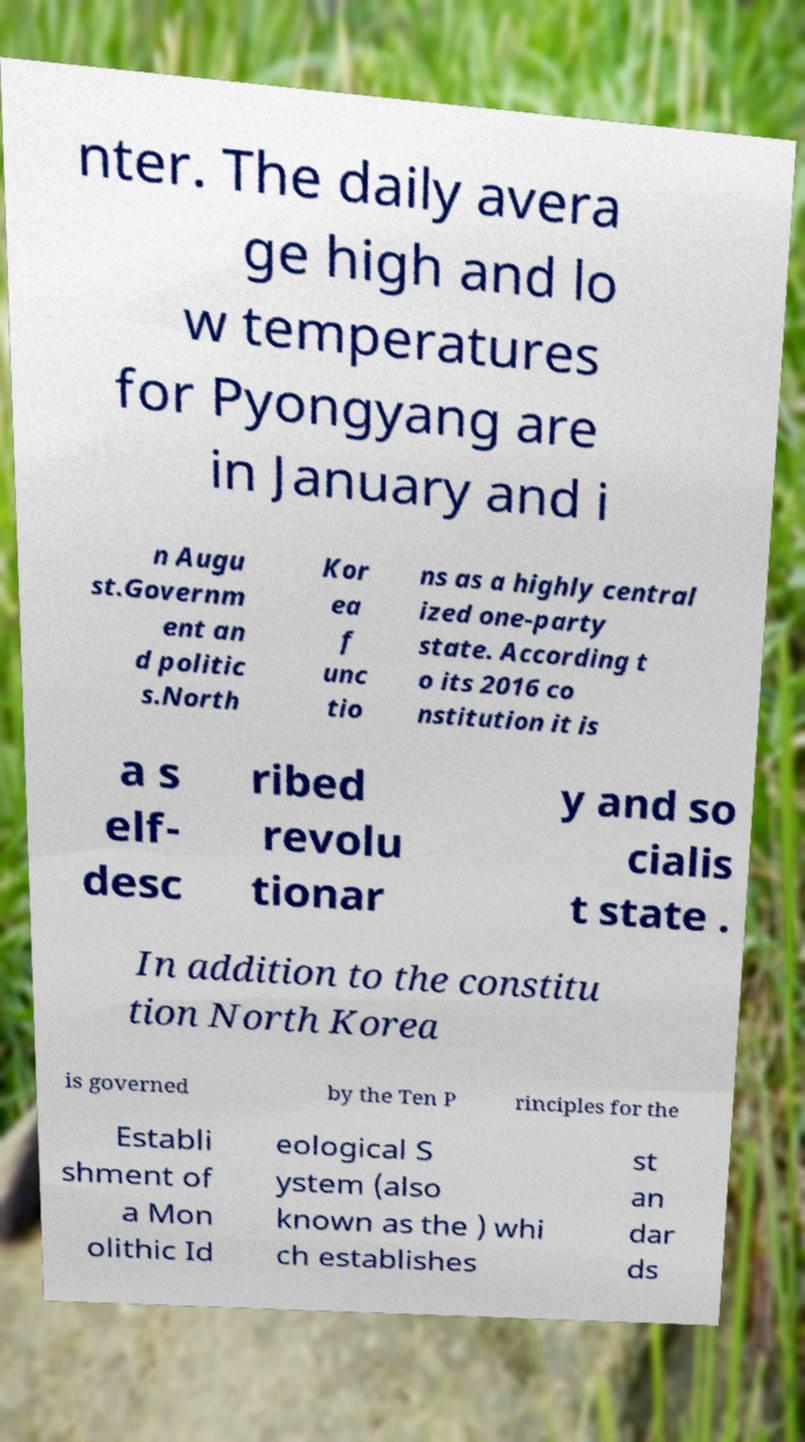Can you read and provide the text displayed in the image?This photo seems to have some interesting text. Can you extract and type it out for me? nter. The daily avera ge high and lo w temperatures for Pyongyang are in January and i n Augu st.Governm ent an d politic s.North Kor ea f unc tio ns as a highly central ized one-party state. According t o its 2016 co nstitution it is a s elf- desc ribed revolu tionar y and so cialis t state . In addition to the constitu tion North Korea is governed by the Ten P rinciples for the Establi shment of a Mon olithic Id eological S ystem (also known as the ) whi ch establishes st an dar ds 